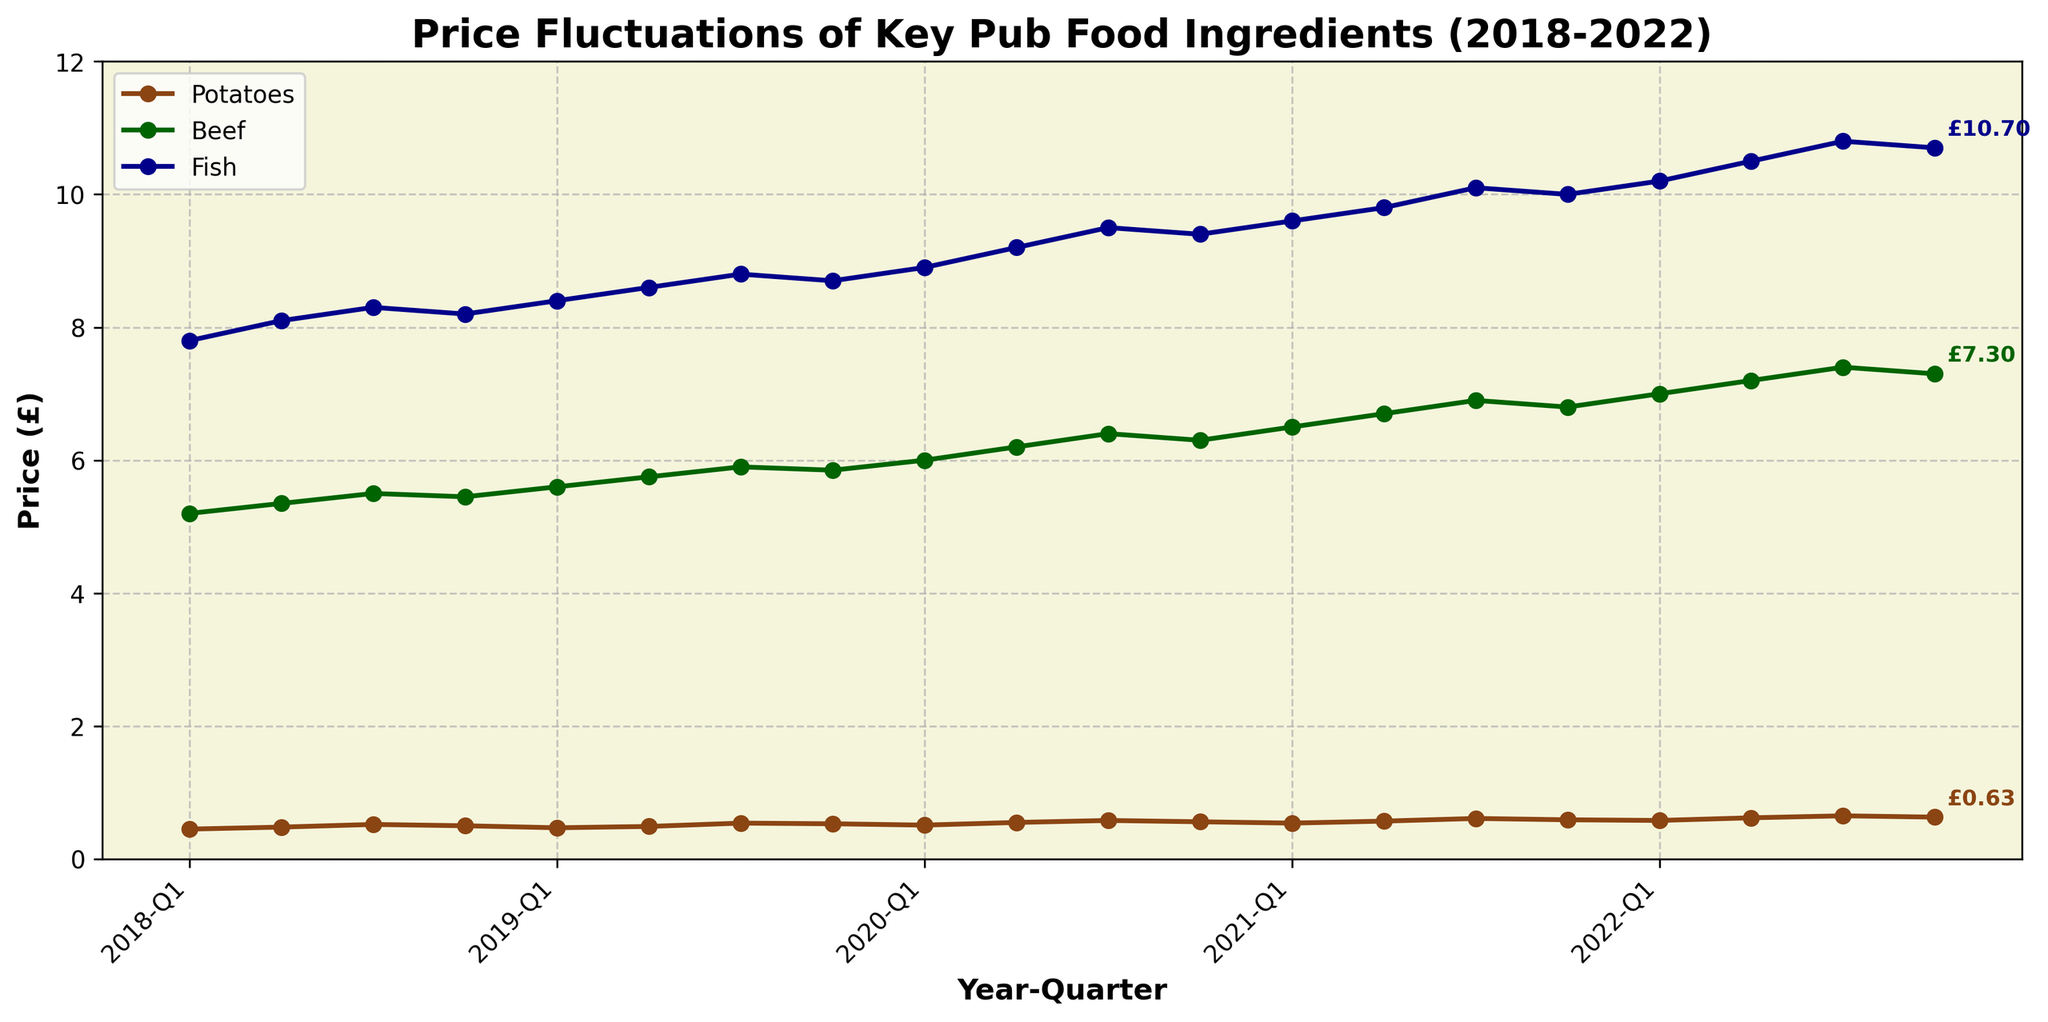What is the overall trend for the price of potatoes from 2018 Q1 to 2022 Q4? The chart shows that the price of potatoes generally increases from 2018 Q1 to 2022 Q4. Starting at around £0.45 in 2018 Q1 and ending at around £0.63 in 2022 Q4.
Answer: Increasing Which ingredient experienced the steepest price increase over the 5-year period? Checking the start and end prices for each ingredient, Fish prices went from £7.80 to £10.70 (increase of £2.90), Beef from £5.20 to £7.30 (increase of £2.10), and Potatoes from £0.45 to £0.63 (increase of £0.18). Fish shows the highest increase.
Answer: Fish In which year did the price of beef first exceed £6? By reviewing the plot, we can see that the price of beef first exceeds £6 in 2020 Q1.
Answer: 2020 How much did the price of fish increase from 2018 Q1 to 2021 Q4? The price of fish was £7.80 in 2018 Q1 and increased to £10.00 in 2021 Q4. The difference is £10.00 - £7.80 = £2.20.
Answer: £2.20 Which ingredient showed the most consistent increase over the period? Comparing the trends, the price of Fish shows a more consistent and steady upward trend with fewer fluctuations compared to Potatoes and Beef which show more variability.
Answer: Fish During which quarter of 2019 did the price of potatoes peak? In 2019, the price of potatoes peaked in Q3 at around £0.54 according to the chart.
Answer: Q3 When did the price of beef experience its highest quarterly increase? The highest quarterly increase for Beef appears to be from 2020 Q4 (~£6.30) to 2021 Q1 (~£6.50), an increase of £0.20.
Answer: 2020 Q4 to 2021 Q1 Which ingredient had the least fluctuation in price? Visually comparing the lines, the price of Beef shows relatively smaller changes and less fluctuation compared to Potatoes and Fish.
Answer: Beef What is the difference in the price of fish between 2020 Q3 and 2022 Q3? The price of Fish in 2020 Q3 was £9.50 and in 2022 Q3 was £10.80. The difference is £10.80 - £9.50 = £1.30.
Answer: £1.30 How did the price of potatoes change from 2019 Q4 to 2020 Q1? The price of Potatoes decreased from £0.53 in 2019 Q4 to £0.51 in 2020 Q1, a decrease of £0.02.
Answer: Decreased by £0.02 